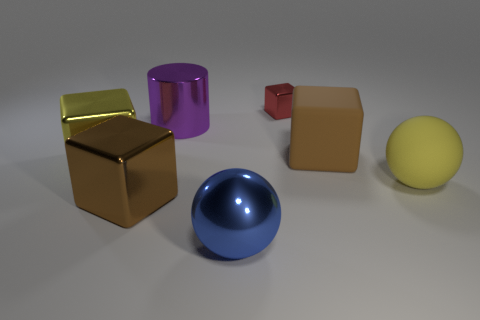Subtract all small blocks. How many blocks are left? 3 Add 3 yellow metallic cubes. How many objects exist? 10 Subtract all yellow cubes. How many cubes are left? 3 Subtract all blocks. How many objects are left? 3 Add 4 metallic cylinders. How many metallic cylinders are left? 5 Add 4 big yellow balls. How many big yellow balls exist? 5 Subtract 0 red spheres. How many objects are left? 7 Subtract 1 balls. How many balls are left? 1 Subtract all purple blocks. Subtract all blue spheres. How many blocks are left? 4 Subtract all brown cylinders. How many cyan spheres are left? 0 